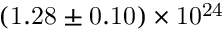<formula> <loc_0><loc_0><loc_500><loc_500>{ ( 1 . 2 8 \pm 0 . 1 0 ) \times 1 0 ^ { 2 4 } }</formula> 